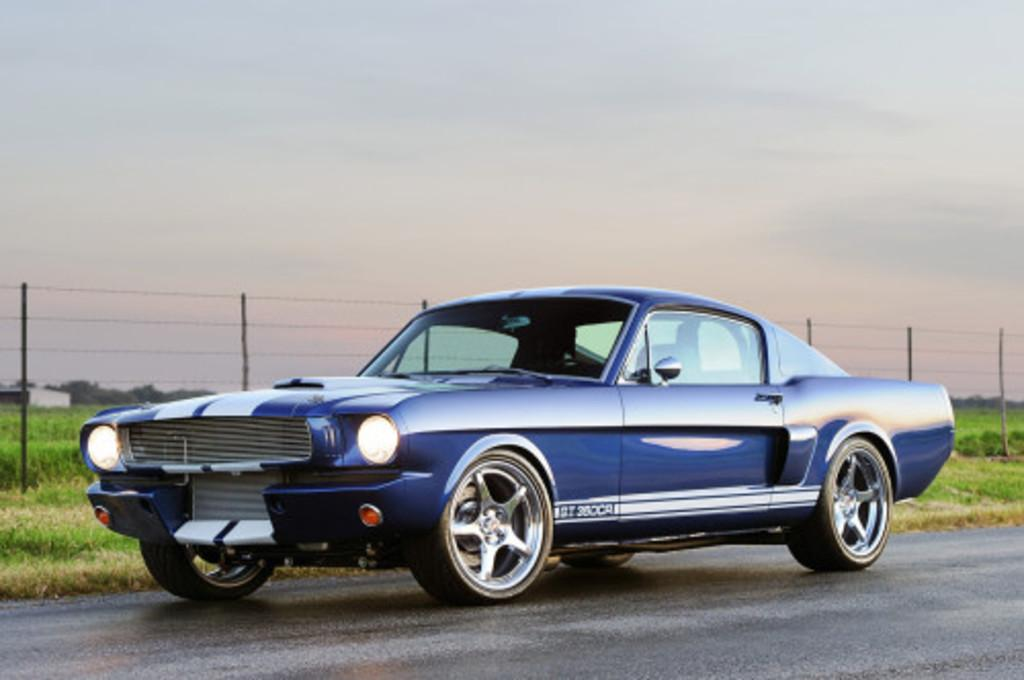What color is the car in the image? The car in the image is blue. Where is the car located? The car is on the road. What can be seen in the background of the image? There is fencing and grass visible in the image. What is visible at the top of the image? The sky is visible at the top of the image. What type of toothbrush is the car using in the image? There is no toothbrush present in the image, as it features a blue car on the road. How many pages are visible in the image? There are no pages present in the image. 